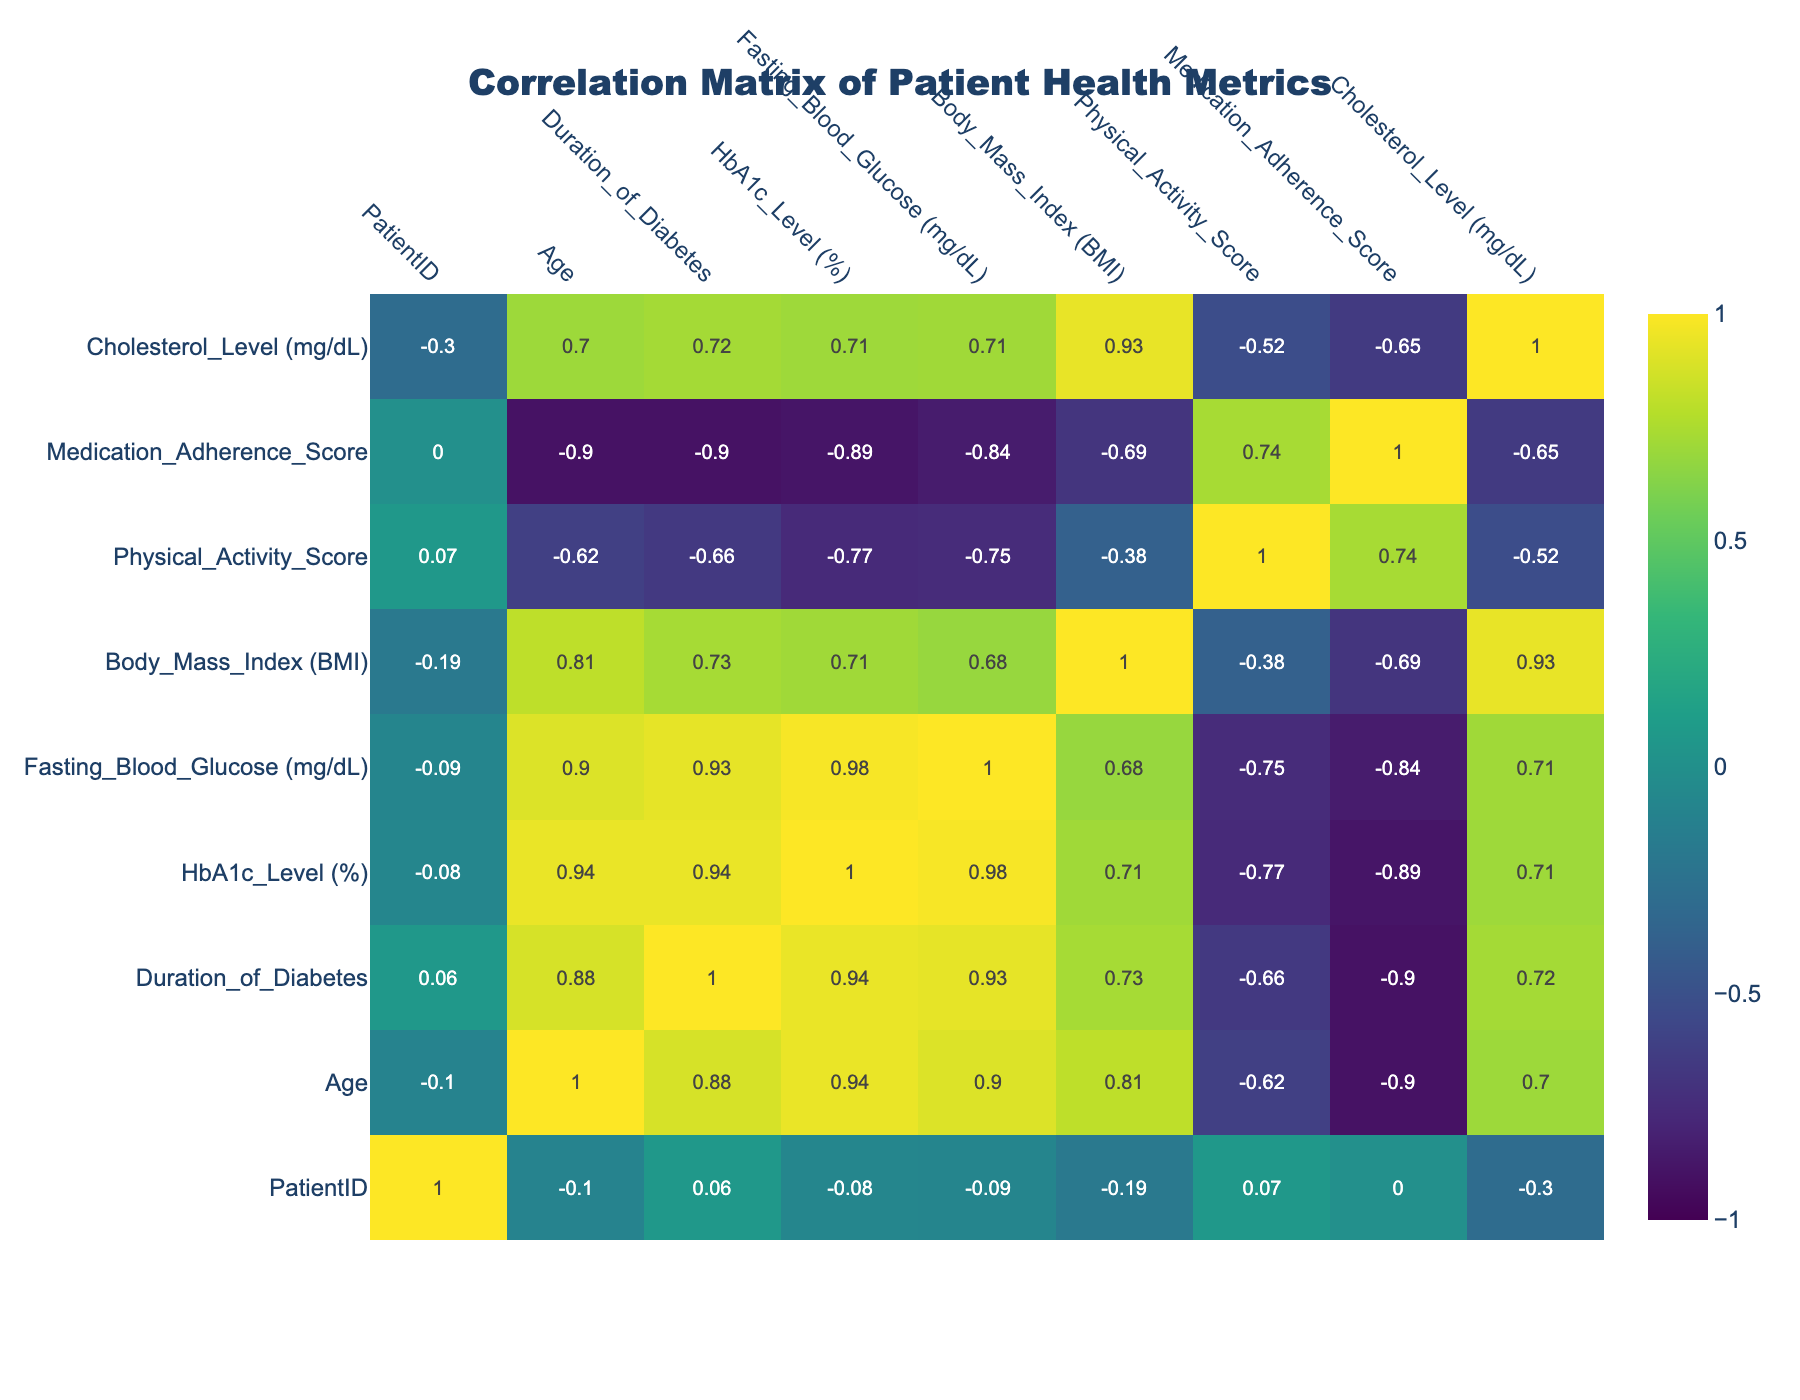What is the correlation coefficient between Age and Fasting Blood Glucose? From the correlation table, I can find the correlation coefficient by checking the relevant intersection. The value at the intersection of the Age and Fasting Blood Glucose row and column is 0.83, indicating a strong positive correlation.
Answer: 0.83 Is there a negative correlation between Physical Activity Score and Cholesterol Level? I look for the value at the intersection of Physical Activity Score and Cholesterol Level in the table. The coefficient is -0.54, which indicates a moderate negative correlation between these two variables.
Answer: Yes What is the average HbA1c Level of patients aged 30 and younger? I first identify the patients aged 30 and younger in the table. The relevant HbA1c Levels are 5.9 and 6.0. The average is calculated as (5.9 + 6.0) / 2 = 5.95.
Answer: 5.95 Do younger patients tend to have higher Medication Adherence Scores? To evaluate this, I would compare the Medication Adherence Scores against the Ages of each patient. Upon inspection, younger patients (like those aged 27 and 30) have scores of 10 and 10, while some older patients have lower scores, indicating that younger patients tend to have higher scores.
Answer: Yes What is the difference in the average Body Mass Index between patients with high HbA1c levels (≥ 7%) and low HbA1c levels (< 7%)? I categorize the patients based on their HbA1c levels. Those with high HbA1c levels (patients 1, 3, 4, 8, and 10) have BMI values of 30.5, 32.0, 28.5, 31.0, and 27.5 respectively; the average is (30.5 + 32.0 + 28.5 + 31.0 + 27.5) / 5 = 29.9. For low HbA1c patients (patients 2, 5, 6, 7, and 9), their BMIs are 25.0, 22.0, 26.5, 29.0, and 24.0 respectively; the average is (25.0 + 22.0 + 26.5 + 29.0 + 24.0) / 5 = 25.53. The difference is 29.9 - 25.53 = 4.37.
Answer: 4.37 Is there a higher duration of diabetes associated with a higher Cholesterol Level? I assess the correlation coefficient between Duration of Diabetes and Cholesterol Level from the correlation table. I find a value of 0.72, which suggests a strong positive relationship meaning that as the duration increases, the cholesterol level tends to increase as well.
Answer: Yes 